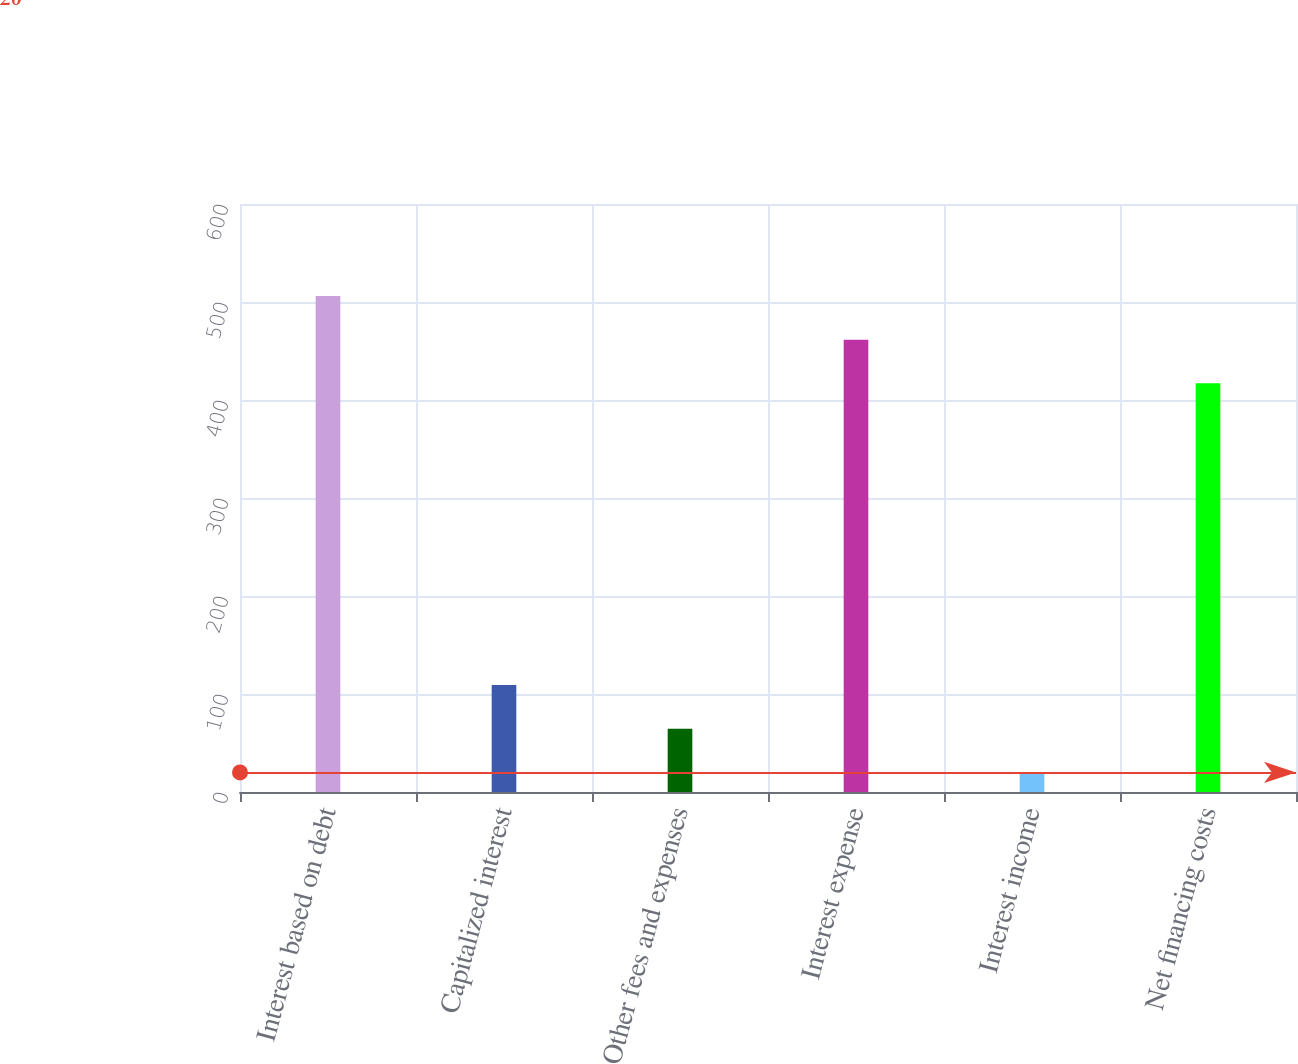<chart> <loc_0><loc_0><loc_500><loc_500><bar_chart><fcel>Interest based on debt<fcel>Capitalized interest<fcel>Other fees and expenses<fcel>Interest expense<fcel>Interest income<fcel>Net financing costs<nl><fcel>506.2<fcel>109.2<fcel>64.6<fcel>461.6<fcel>20<fcel>417<nl></chart> 